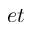<formula> <loc_0><loc_0><loc_500><loc_500>e t</formula> 